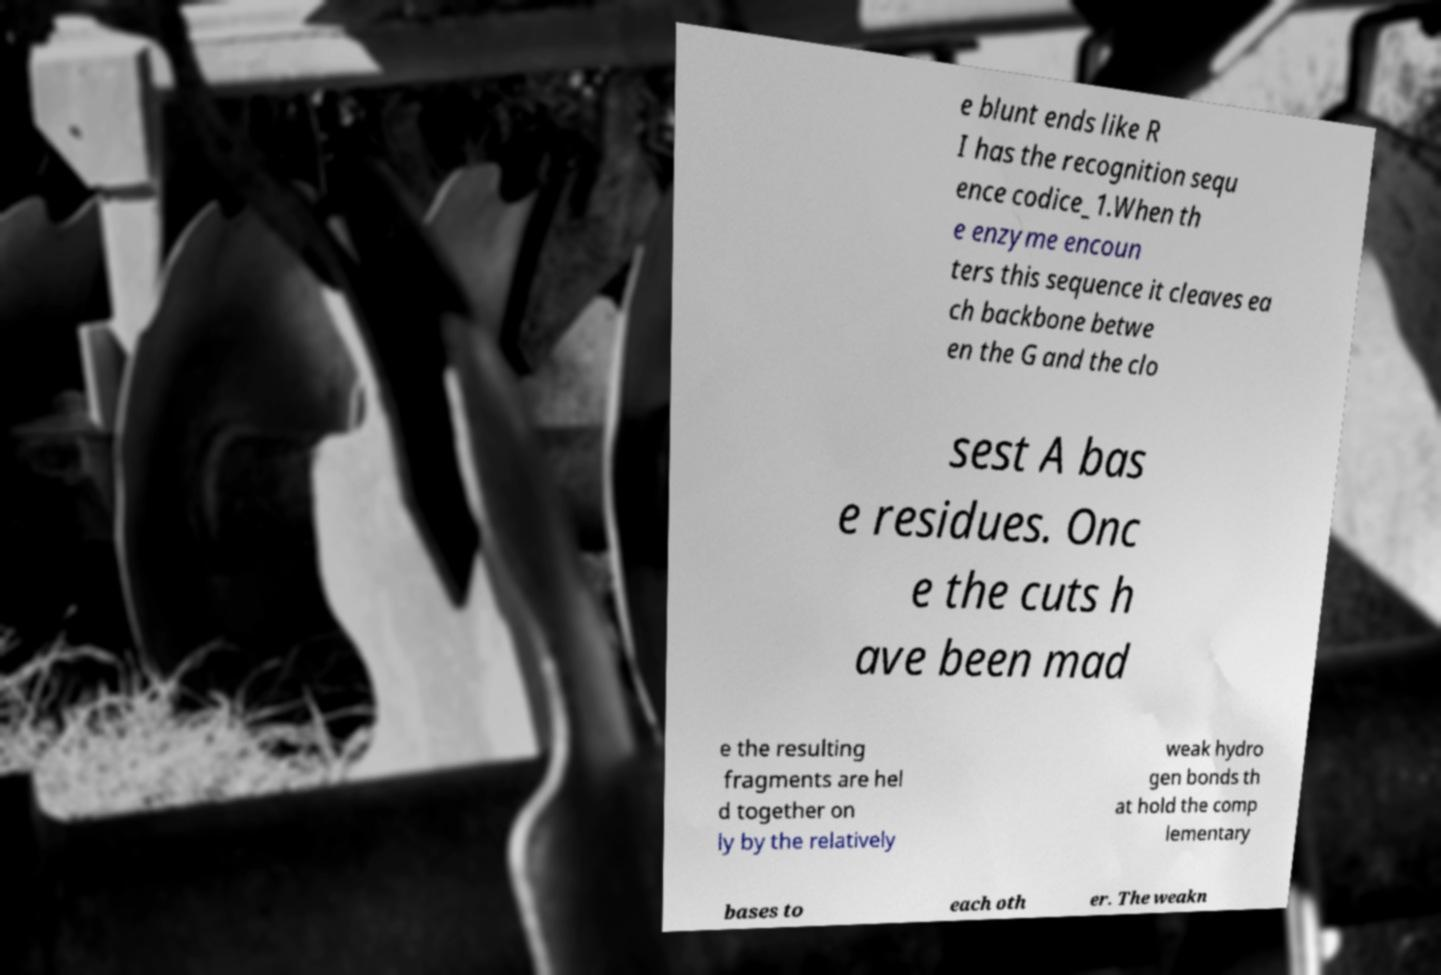For documentation purposes, I need the text within this image transcribed. Could you provide that? e blunt ends like R I has the recognition sequ ence codice_1.When th e enzyme encoun ters this sequence it cleaves ea ch backbone betwe en the G and the clo sest A bas e residues. Onc e the cuts h ave been mad e the resulting fragments are hel d together on ly by the relatively weak hydro gen bonds th at hold the comp lementary bases to each oth er. The weakn 